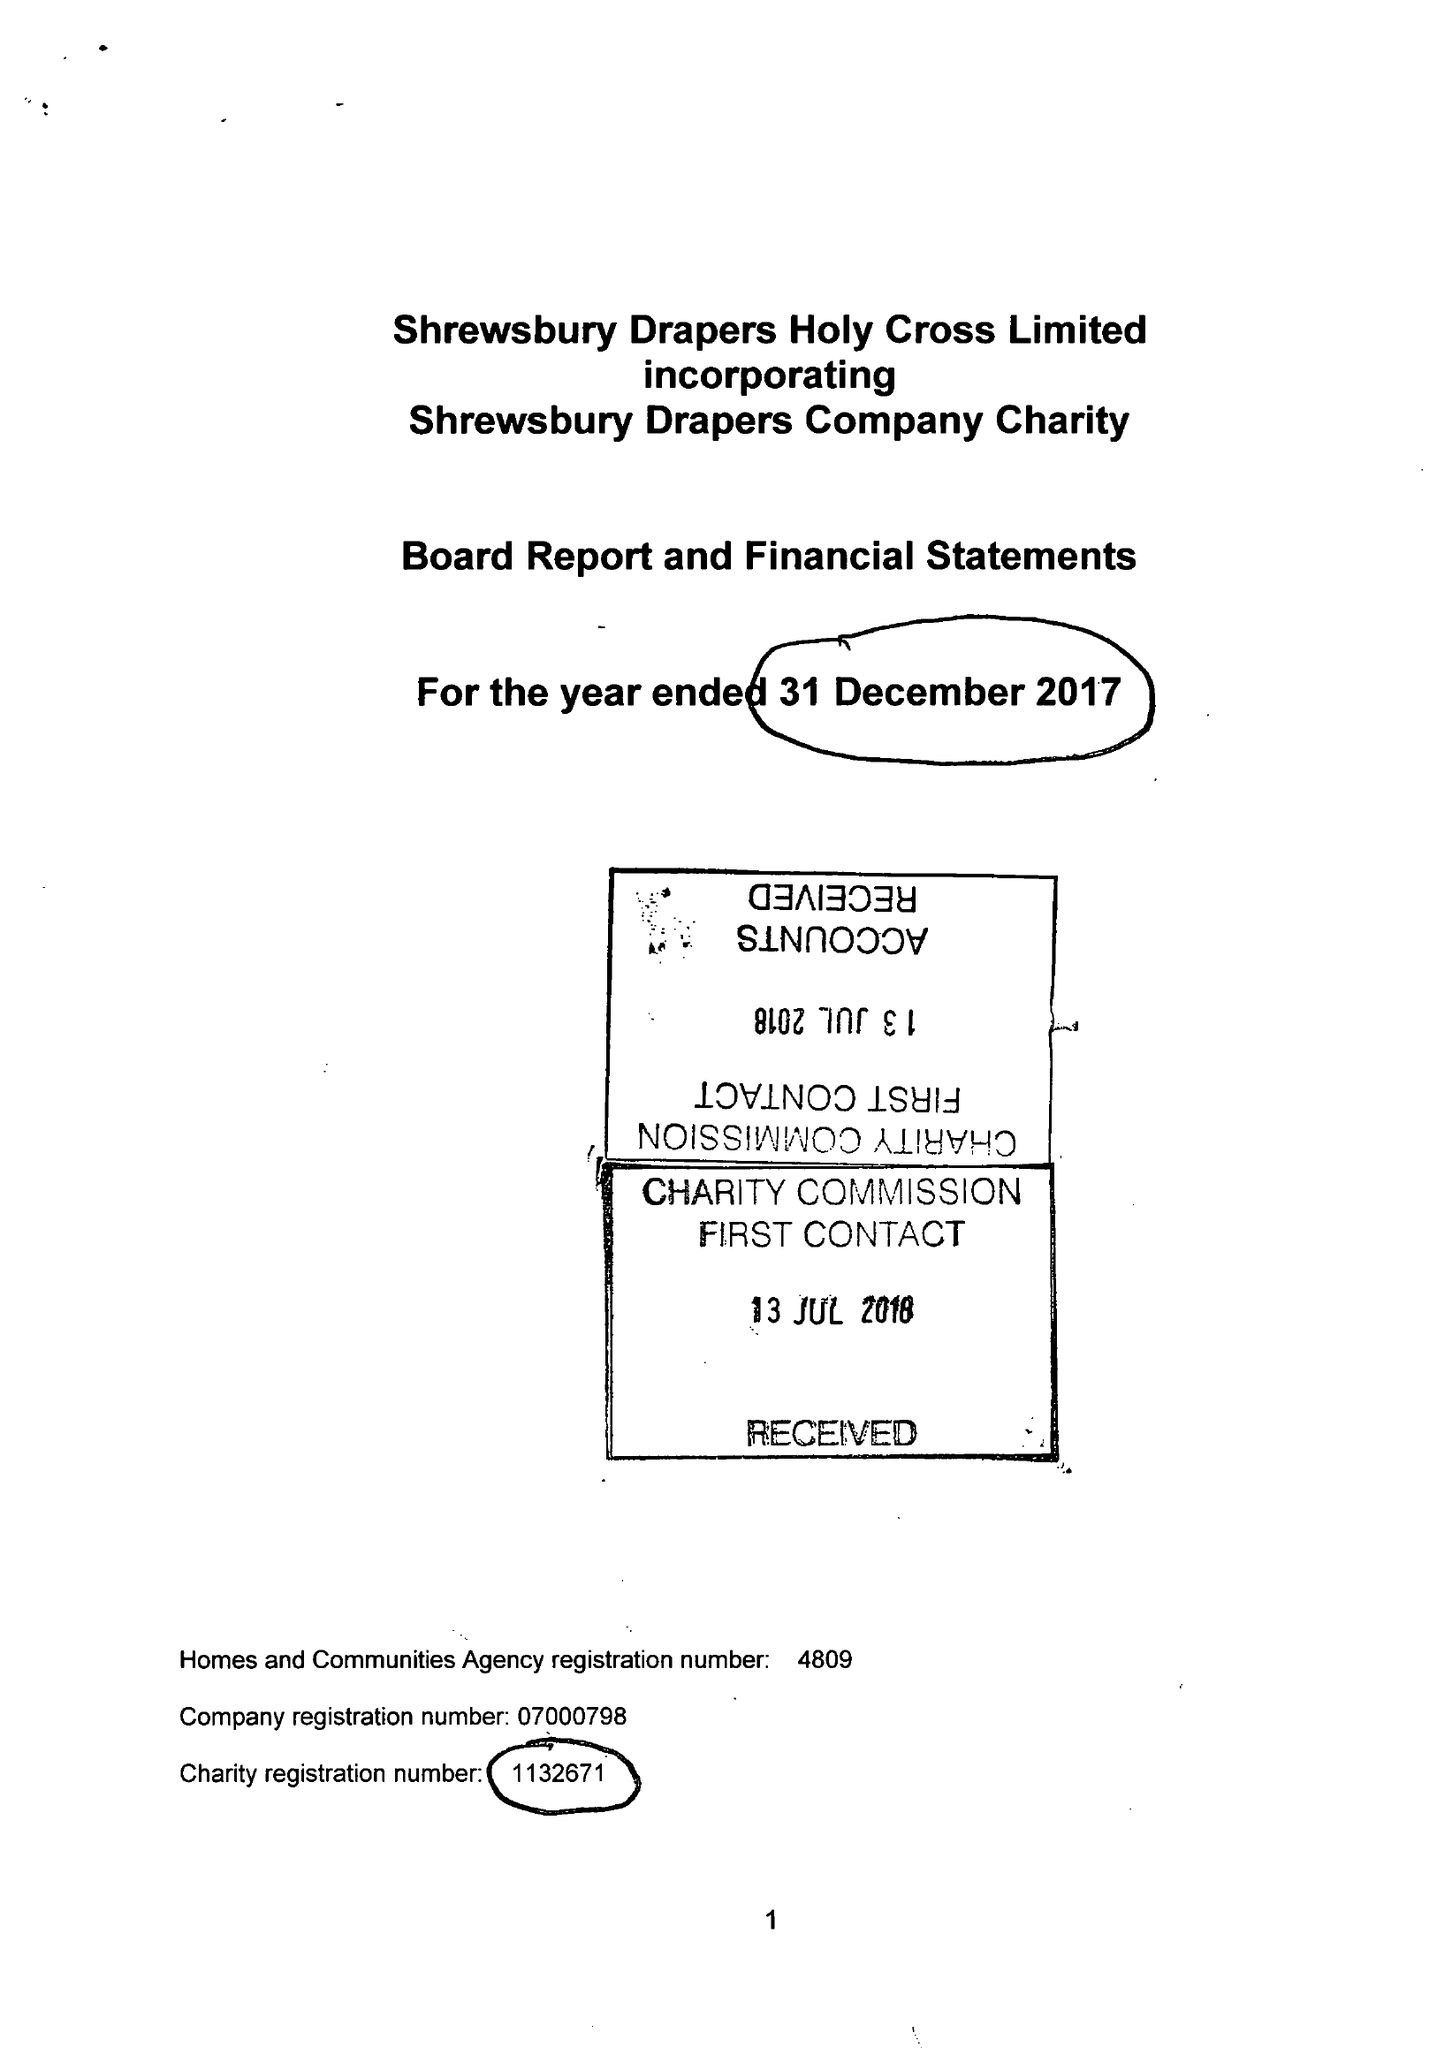What is the value for the charity_name?
Answer the question using a single word or phrase. Shrewsbury Drapers Holy Cross Ltd. 